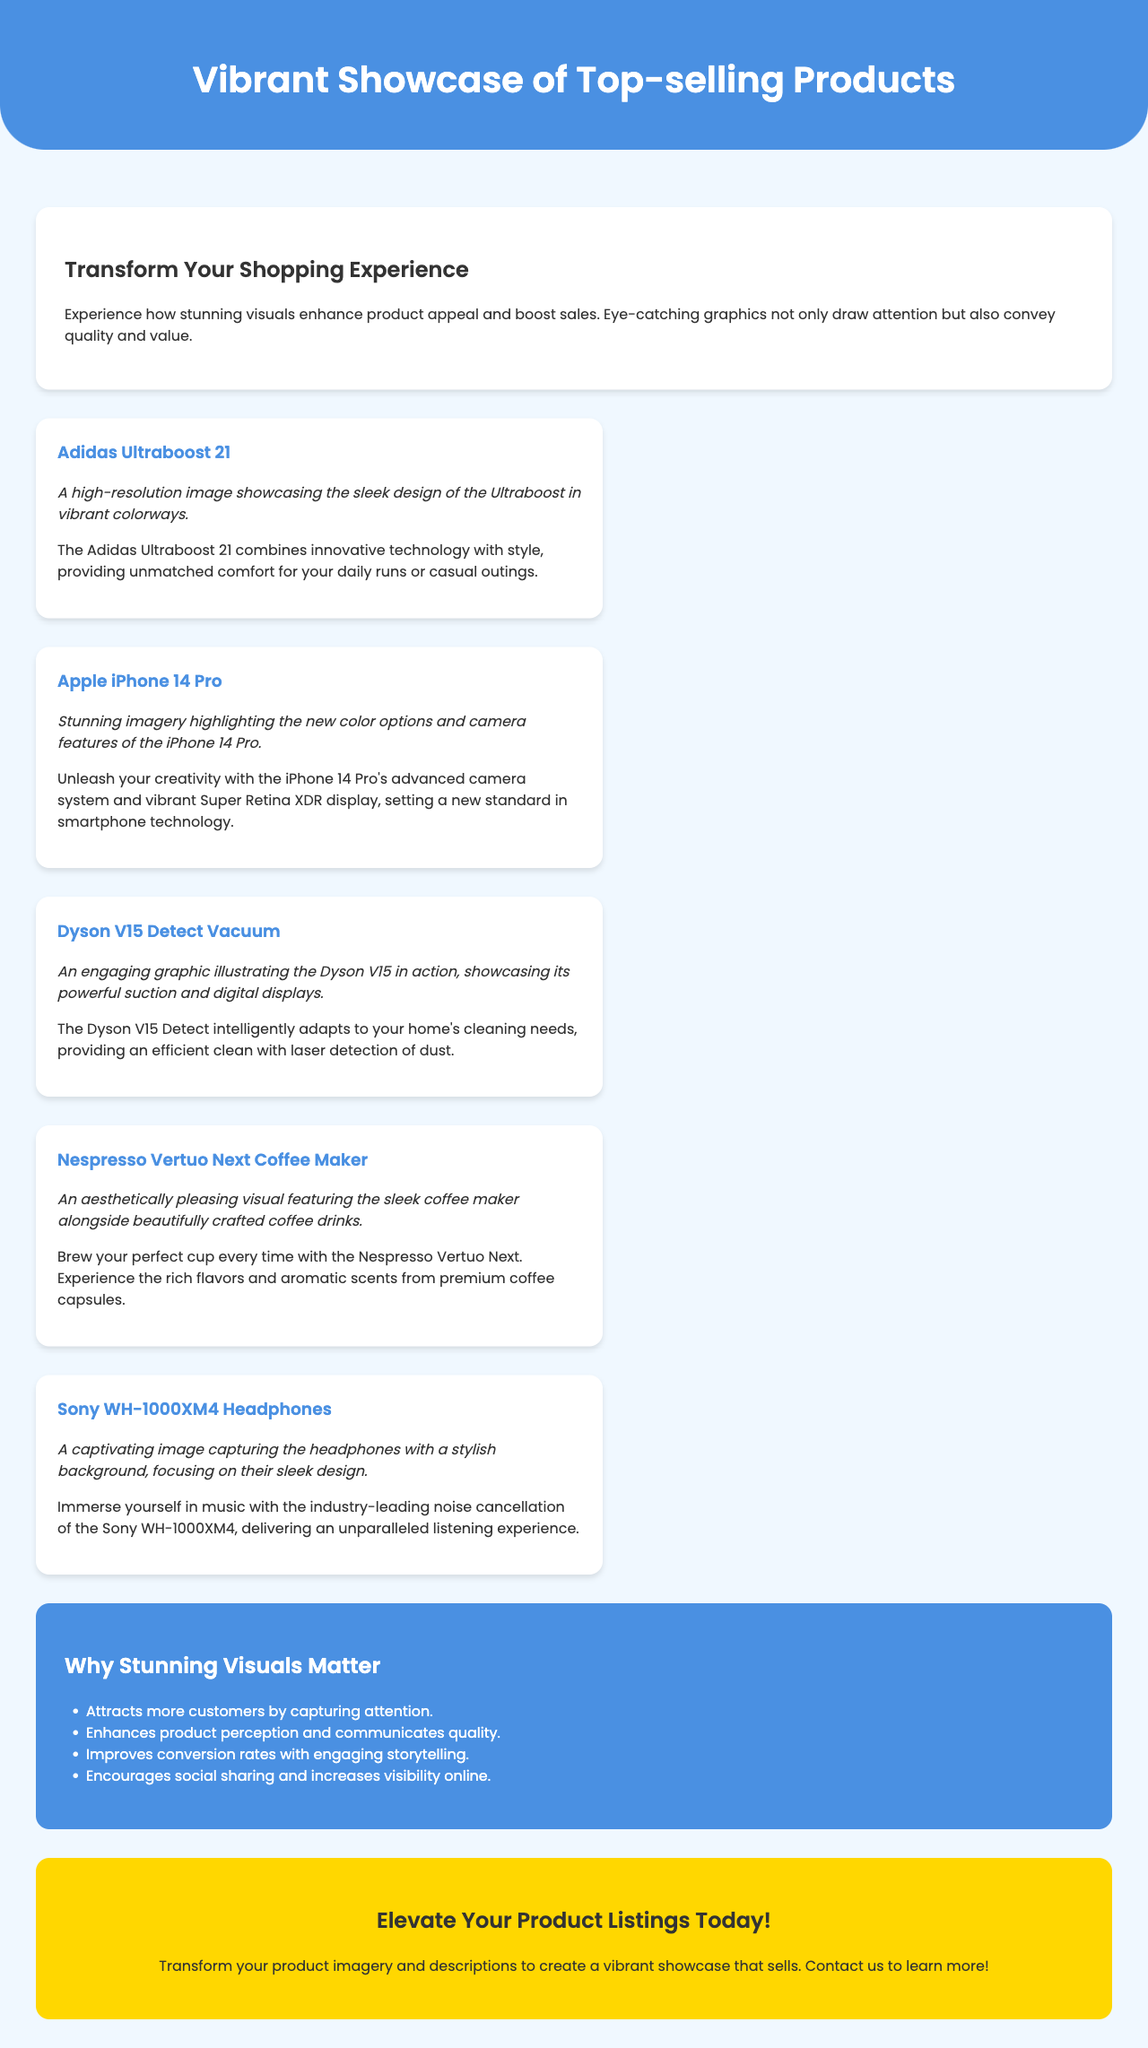What is the title of the brochure? The title of the brochure is found in the header section at the top of the document.
Answer: Vibrant Showcase of Top-selling Products What product is highlighted as providing unmatched comfort? The product that combines innovative technology with style, providing comfort, is mentioned in the product description.
Answer: Adidas Ultraboost 21 How many products are showcased in the brochure? The number of products showcased can be counted in the products section of the document.
Answer: Five What color is the background of the impact section? The impact section has a background color specified in the style section of the document.
Answer: #4a90e2 Which product features an advanced camera system? This product is specified in the product description, highlighting its camera features.
Answer: Apple iPhone 14 Pro What is one benefit of stunning visuals mentioned in the brochure? The brochure lists benefits in the impact section that can be referenced for specific advantages.
Answer: Attracts more customers by capturing attention What kind of product is the Dyson V15 Detect? This can be deduced from the context of its description in the products section.
Answer: Vacuum What is the call to action in the brochure? The call to action can be found in the cta section encouraging specific user engagement.
Answer: Elevate Your Product Listings Today! 